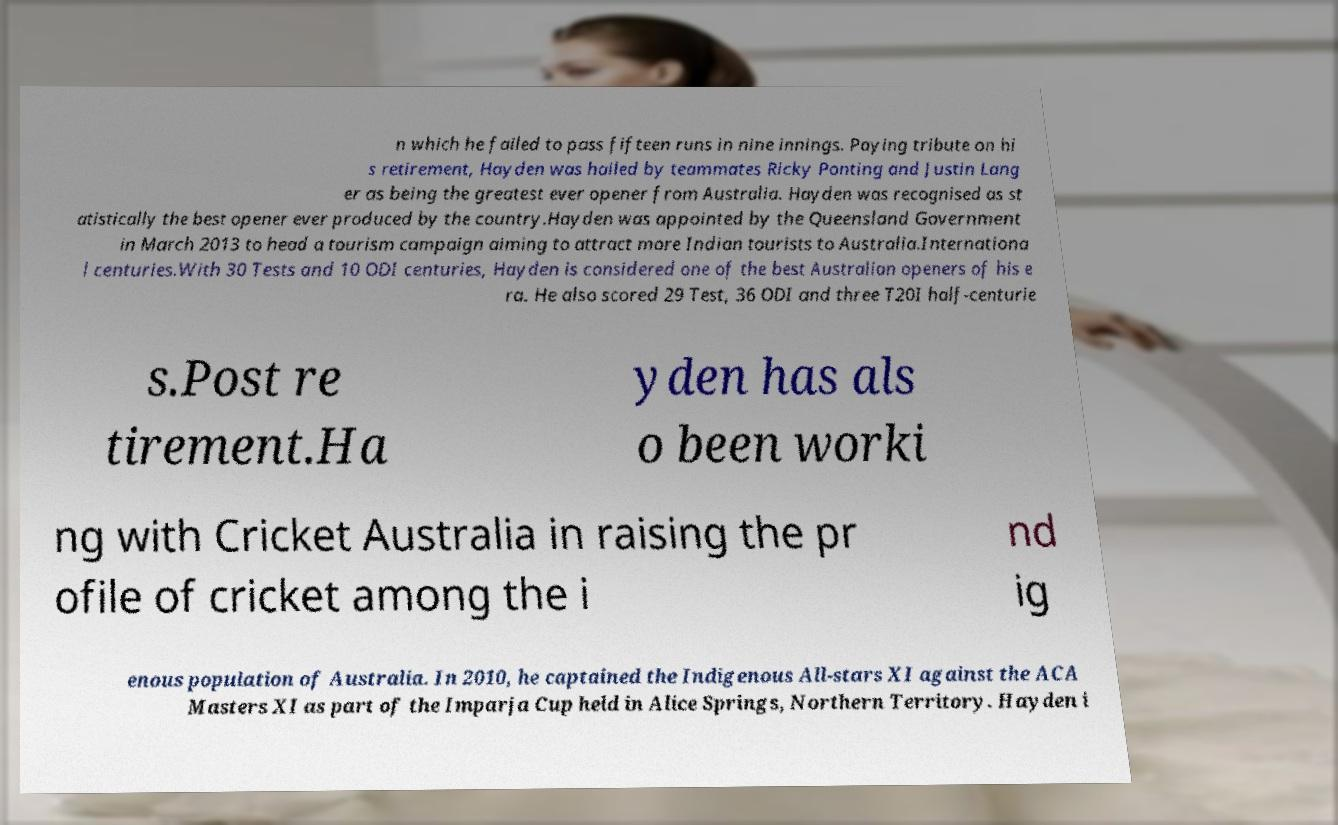Can you read and provide the text displayed in the image?This photo seems to have some interesting text. Can you extract and type it out for me? n which he failed to pass fifteen runs in nine innings. Paying tribute on hi s retirement, Hayden was hailed by teammates Ricky Ponting and Justin Lang er as being the greatest ever opener from Australia. Hayden was recognised as st atistically the best opener ever produced by the country.Hayden was appointed by the Queensland Government in March 2013 to head a tourism campaign aiming to attract more Indian tourists to Australia.Internationa l centuries.With 30 Tests and 10 ODI centuries, Hayden is considered one of the best Australian openers of his e ra. He also scored 29 Test, 36 ODI and three T20I half-centurie s.Post re tirement.Ha yden has als o been worki ng with Cricket Australia in raising the pr ofile of cricket among the i nd ig enous population of Australia. In 2010, he captained the Indigenous All-stars XI against the ACA Masters XI as part of the Imparja Cup held in Alice Springs, Northern Territory. Hayden i 